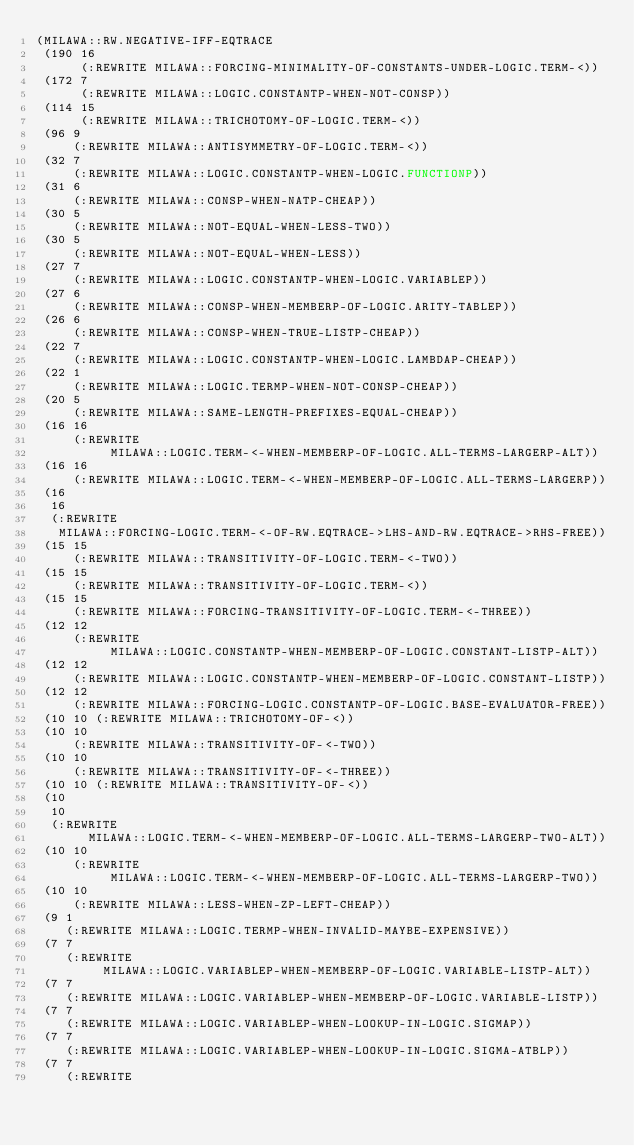Convert code to text. <code><loc_0><loc_0><loc_500><loc_500><_Lisp_>(MILAWA::RW.NEGATIVE-IFF-EQTRACE
 (190 16
      (:REWRITE MILAWA::FORCING-MINIMALITY-OF-CONSTANTS-UNDER-LOGIC.TERM-<))
 (172 7
      (:REWRITE MILAWA::LOGIC.CONSTANTP-WHEN-NOT-CONSP))
 (114 15
      (:REWRITE MILAWA::TRICHOTOMY-OF-LOGIC.TERM-<))
 (96 9
     (:REWRITE MILAWA::ANTISYMMETRY-OF-LOGIC.TERM-<))
 (32 7
     (:REWRITE MILAWA::LOGIC.CONSTANTP-WHEN-LOGIC.FUNCTIONP))
 (31 6
     (:REWRITE MILAWA::CONSP-WHEN-NATP-CHEAP))
 (30 5
     (:REWRITE MILAWA::NOT-EQUAL-WHEN-LESS-TWO))
 (30 5
     (:REWRITE MILAWA::NOT-EQUAL-WHEN-LESS))
 (27 7
     (:REWRITE MILAWA::LOGIC.CONSTANTP-WHEN-LOGIC.VARIABLEP))
 (27 6
     (:REWRITE MILAWA::CONSP-WHEN-MEMBERP-OF-LOGIC.ARITY-TABLEP))
 (26 6
     (:REWRITE MILAWA::CONSP-WHEN-TRUE-LISTP-CHEAP))
 (22 7
     (:REWRITE MILAWA::LOGIC.CONSTANTP-WHEN-LOGIC.LAMBDAP-CHEAP))
 (22 1
     (:REWRITE MILAWA::LOGIC.TERMP-WHEN-NOT-CONSP-CHEAP))
 (20 5
     (:REWRITE MILAWA::SAME-LENGTH-PREFIXES-EQUAL-CHEAP))
 (16 16
     (:REWRITE
          MILAWA::LOGIC.TERM-<-WHEN-MEMBERP-OF-LOGIC.ALL-TERMS-LARGERP-ALT))
 (16 16
     (:REWRITE MILAWA::LOGIC.TERM-<-WHEN-MEMBERP-OF-LOGIC.ALL-TERMS-LARGERP))
 (16
  16
  (:REWRITE
   MILAWA::FORCING-LOGIC.TERM-<-OF-RW.EQTRACE->LHS-AND-RW.EQTRACE->RHS-FREE))
 (15 15
     (:REWRITE MILAWA::TRANSITIVITY-OF-LOGIC.TERM-<-TWO))
 (15 15
     (:REWRITE MILAWA::TRANSITIVITY-OF-LOGIC.TERM-<))
 (15 15
     (:REWRITE MILAWA::FORCING-TRANSITIVITY-OF-LOGIC.TERM-<-THREE))
 (12 12
     (:REWRITE
          MILAWA::LOGIC.CONSTANTP-WHEN-MEMBERP-OF-LOGIC.CONSTANT-LISTP-ALT))
 (12 12
     (:REWRITE MILAWA::LOGIC.CONSTANTP-WHEN-MEMBERP-OF-LOGIC.CONSTANT-LISTP))
 (12 12
     (:REWRITE MILAWA::FORCING-LOGIC.CONSTANTP-OF-LOGIC.BASE-EVALUATOR-FREE))
 (10 10 (:REWRITE MILAWA::TRICHOTOMY-OF-<))
 (10 10
     (:REWRITE MILAWA::TRANSITIVITY-OF-<-TWO))
 (10 10
     (:REWRITE MILAWA::TRANSITIVITY-OF-<-THREE))
 (10 10 (:REWRITE MILAWA::TRANSITIVITY-OF-<))
 (10
  10
  (:REWRITE
       MILAWA::LOGIC.TERM-<-WHEN-MEMBERP-OF-LOGIC.ALL-TERMS-LARGERP-TWO-ALT))
 (10 10
     (:REWRITE
          MILAWA::LOGIC.TERM-<-WHEN-MEMBERP-OF-LOGIC.ALL-TERMS-LARGERP-TWO))
 (10 10
     (:REWRITE MILAWA::LESS-WHEN-ZP-LEFT-CHEAP))
 (9 1
    (:REWRITE MILAWA::LOGIC.TERMP-WHEN-INVALID-MAYBE-EXPENSIVE))
 (7 7
    (:REWRITE
         MILAWA::LOGIC.VARIABLEP-WHEN-MEMBERP-OF-LOGIC.VARIABLE-LISTP-ALT))
 (7 7
    (:REWRITE MILAWA::LOGIC.VARIABLEP-WHEN-MEMBERP-OF-LOGIC.VARIABLE-LISTP))
 (7 7
    (:REWRITE MILAWA::LOGIC.VARIABLEP-WHEN-LOOKUP-IN-LOGIC.SIGMAP))
 (7 7
    (:REWRITE MILAWA::LOGIC.VARIABLEP-WHEN-LOOKUP-IN-LOGIC.SIGMA-ATBLP))
 (7 7
    (:REWRITE</code> 